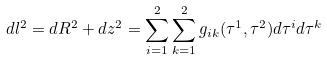<formula> <loc_0><loc_0><loc_500><loc_500>d l ^ { 2 } = d R ^ { 2 } + d z ^ { 2 } = \sum ^ { 2 } _ { i = 1 } \sum ^ { 2 } _ { k = 1 } g _ { i k } ( \tau ^ { 1 } , \tau ^ { 2 } ) d \tau ^ { i } d \tau ^ { k }</formula> 